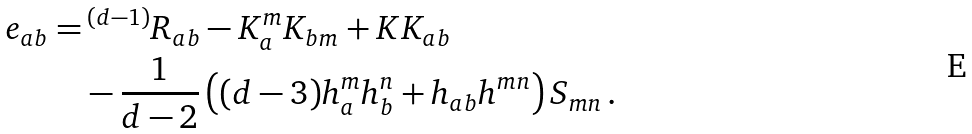<formula> <loc_0><loc_0><loc_500><loc_500>e _ { a b } = & \, ^ { ( d - 1 ) } R _ { a b } - K _ { a } ^ { m } K _ { b m } + K K _ { a b } \\ & - \frac { 1 } { d - 2 } \left ( ( d - 3 ) h _ { a } ^ { m } h _ { b } ^ { n } + h _ { a b } h ^ { m n } \right ) S _ { m n } \, .</formula> 